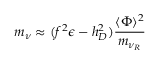<formula> <loc_0><loc_0><loc_500><loc_500>m _ { \nu } \approx ( f ^ { 2 } \epsilon - h _ { D } ^ { 2 } ) { \frac { \langle \Phi \rangle ^ { 2 } } { m _ { \nu _ { R } } } }</formula> 